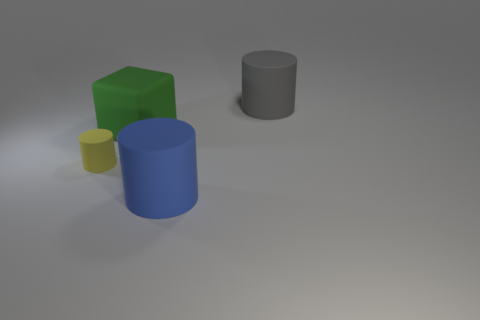Is the shape of the gray thing the same as the big green matte thing? no 